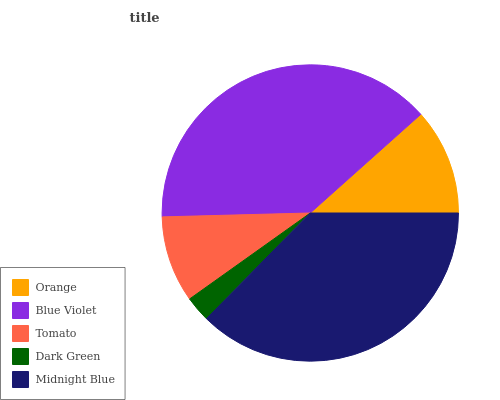Is Dark Green the minimum?
Answer yes or no. Yes. Is Blue Violet the maximum?
Answer yes or no. Yes. Is Tomato the minimum?
Answer yes or no. No. Is Tomato the maximum?
Answer yes or no. No. Is Blue Violet greater than Tomato?
Answer yes or no. Yes. Is Tomato less than Blue Violet?
Answer yes or no. Yes. Is Tomato greater than Blue Violet?
Answer yes or no. No. Is Blue Violet less than Tomato?
Answer yes or no. No. Is Orange the high median?
Answer yes or no. Yes. Is Orange the low median?
Answer yes or no. Yes. Is Blue Violet the high median?
Answer yes or no. No. Is Midnight Blue the low median?
Answer yes or no. No. 